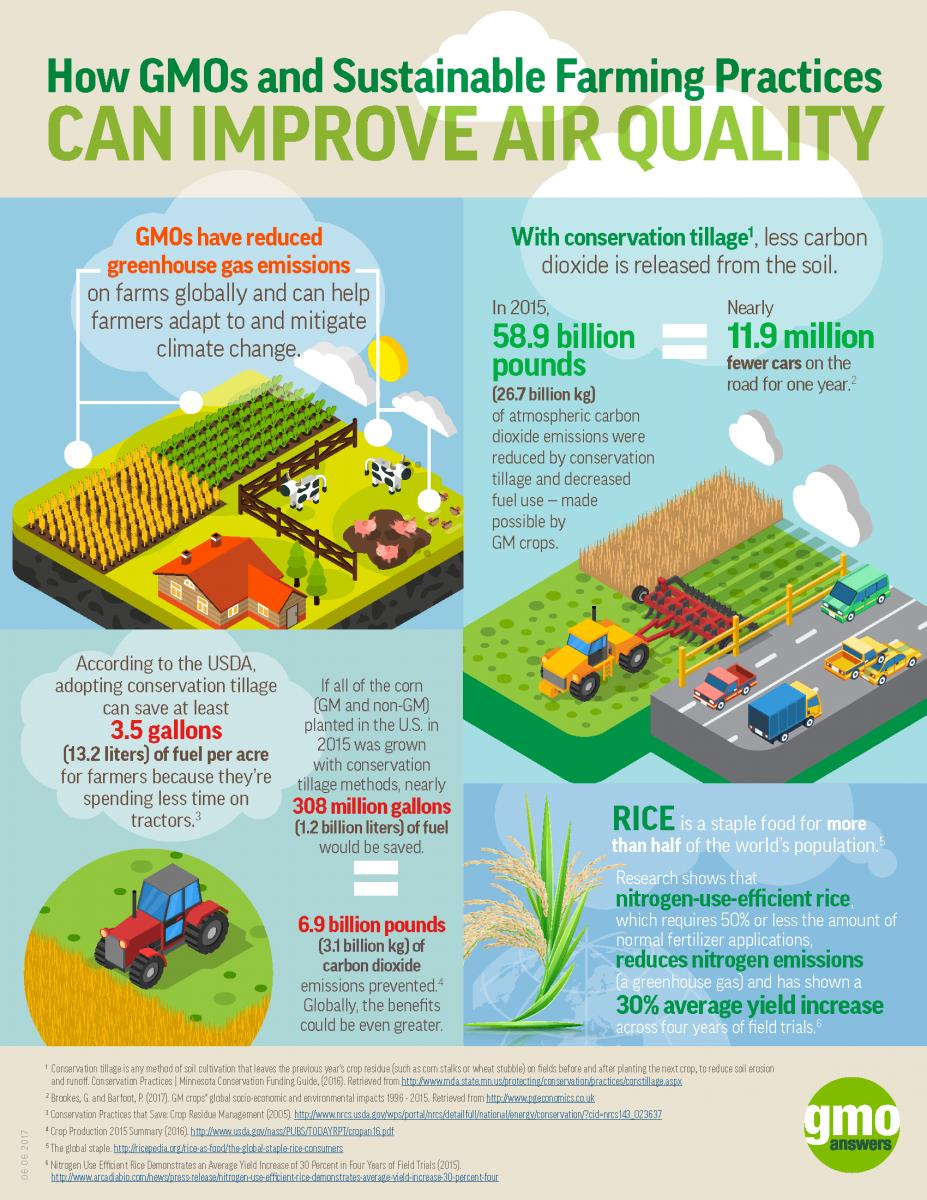Draw attention to some important aspects in this diagram. In the infographic, there are two cows. There is only one house depicted in this infographic. The number of vehicles in the infographic is 7. 